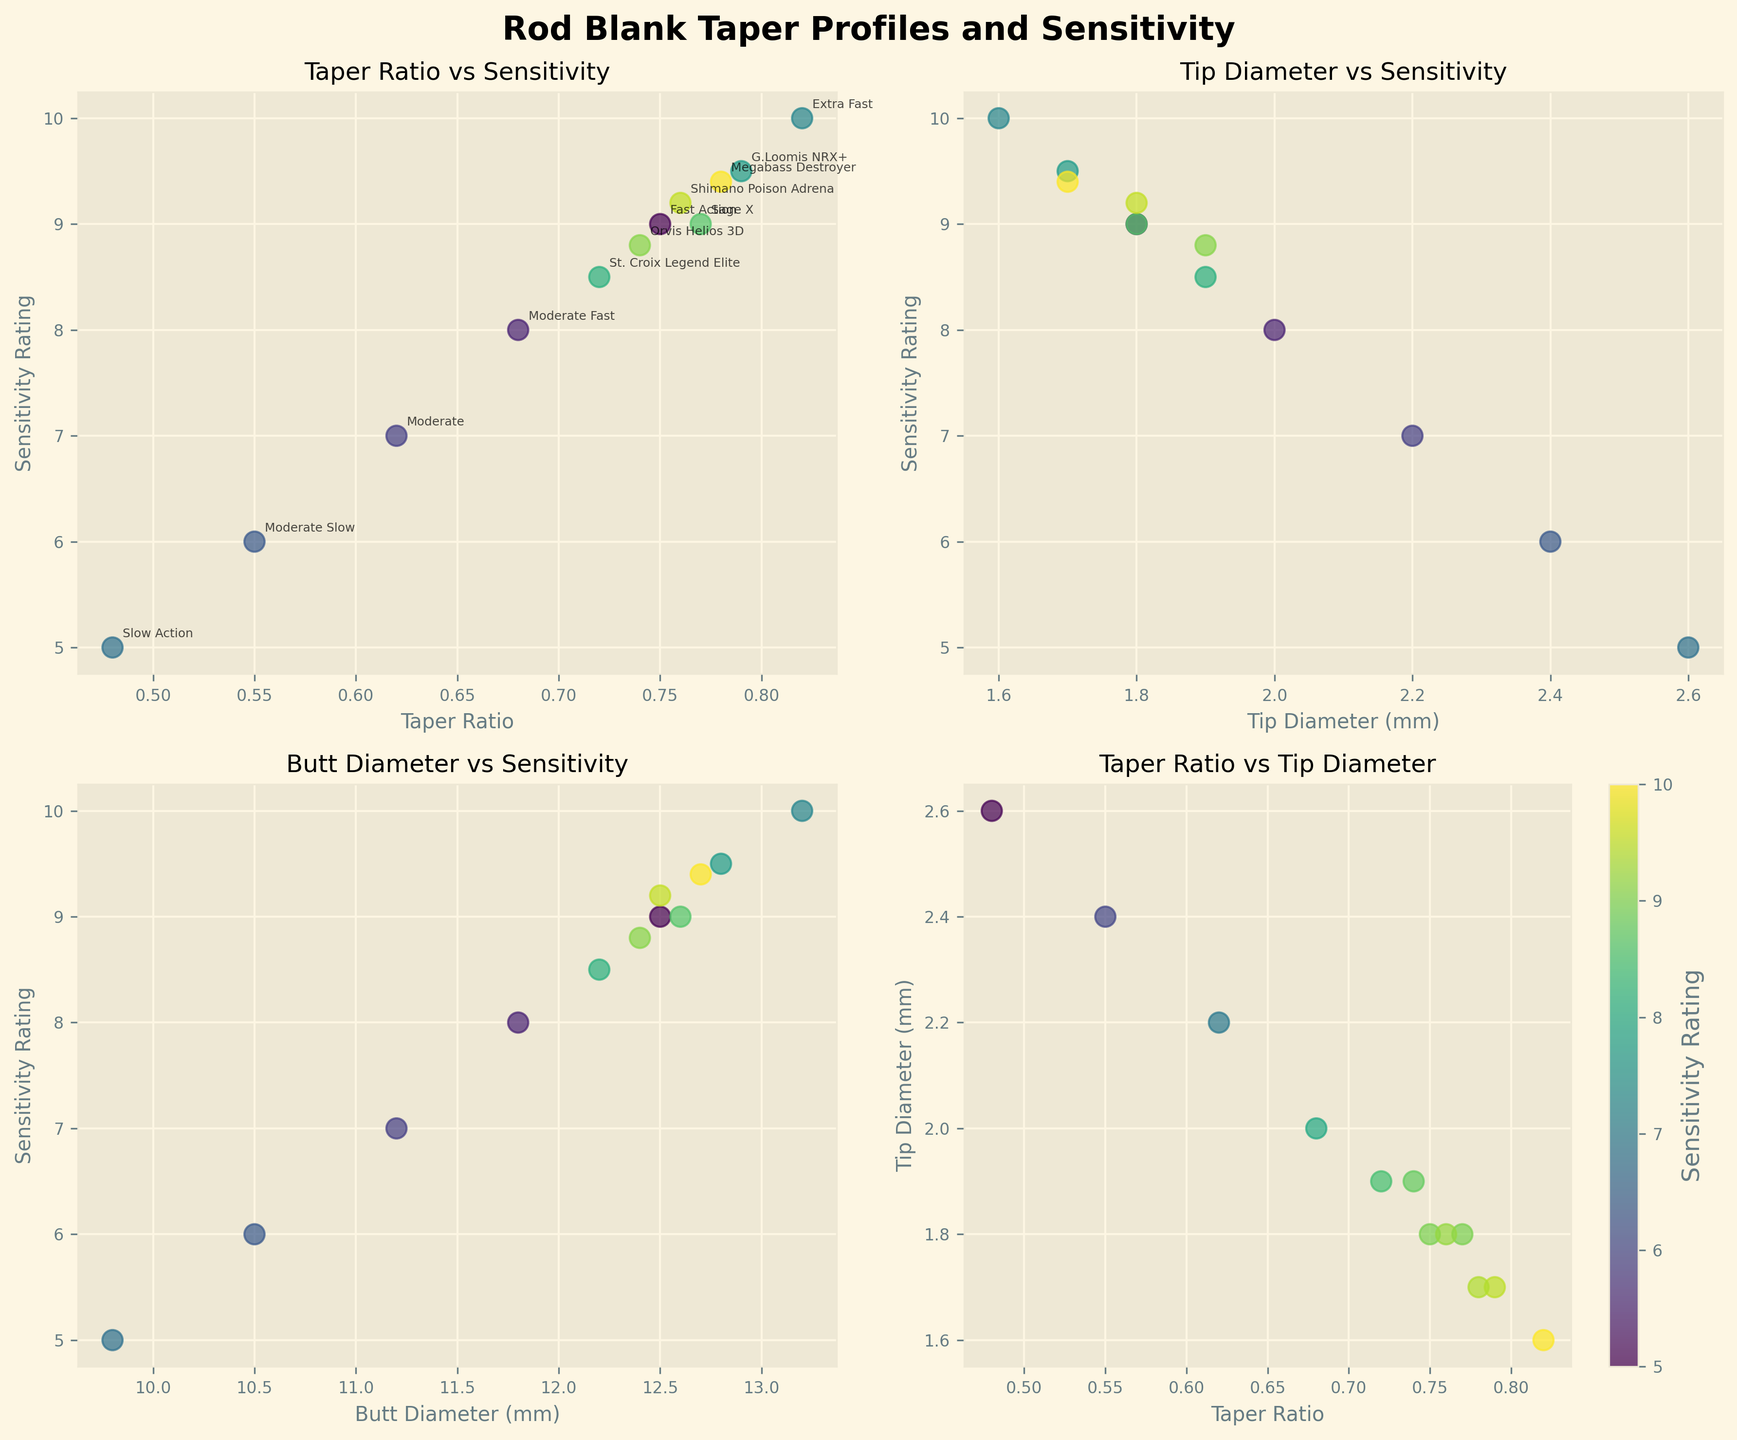How many scatter plots are presented in the figure? The figure contains four scatter plots arranged in a 2x2 grid.
Answer: Four What is the title of the scatter plot in the bottom left corner? The title of the scatter plot in the bottom left corner reads 'Butt Diameter vs Sensitivity'.
Answer: 'Butt Diameter vs Sensitivity' Which rod type has the highest Sensitivity Rating, and what is its Taper Ratio? The rod type "Extra Fast" has the highest Sensitivity Rating of 10, and its Taper Ratio is 0.82.
Answer: Extra Fast, 0.82 Comparing the G.Loomis NRX+ and Sage X rods, which one has a higher Sensitivity Rating? The G.Loomis NRX+ rod has a Sensitivity Rating of 9.5, while the Sage X rod has a rating of 9. Thus, G.Loomis NRX+ has a higher Sensitivity Rating.
Answer: G.Loomis NRX+ What is the relationship between Taper Ratio and Sensitivity Rating as shown in the top left scatter plot? In the top left scatter plot, as the Taper Ratio increases, the Sensitivity Rating also increases, indicating a positive correlation between the two variables.
Answer: Positive correlation Which rod type has the smallest Tip Diameter, and what is its Sensitivity Rating? The "Extra Fast" rod has the smallest Tip Diameter of 1.6 mm, and its Sensitivity Rating is 10.
Answer: Extra Fast, 10 Does the scatter plot at the bottom right have a color bar, and what does it represent? Yes, the bottom right scatter plot has a color bar, which represents the Sensitivity Rating of the rods.
Answer: Yes, Sensitivity Rating Looking at the scatter plot of 'Taper Ratio vs Tip Diameter,' which rod type shows a Taper Ratio of about 0.77 and a Tip Diameter of 1.8 mm? The "Sage X" rod shows a Taper Ratio of 0.77 and a Tip Diameter of 1.8 mm in the 'Taper Ratio vs Tip Diameter' scatter plot.
Answer: Sage X Which rod type is the most sensitive among those with a Taper Ratio below 0.6? The "Moderate" rod type, with a Taper Ratio of 0.62 and a Sensitivity Rating of 7, is the most sensitive among those with a Taper Ratio below 0.6.
Answer: Moderate What is the common feature of the rods that have a Sensitivity Rating of 9 or above? In the scatter plots, rods with a Sensitivity Rating of 9 or above generally have a Taper Ratio above 0.75 and smaller Tip Diameters around 1.6 to 1.8 mm.
Answer: High Taper Ratio, Small Tip Diameter 